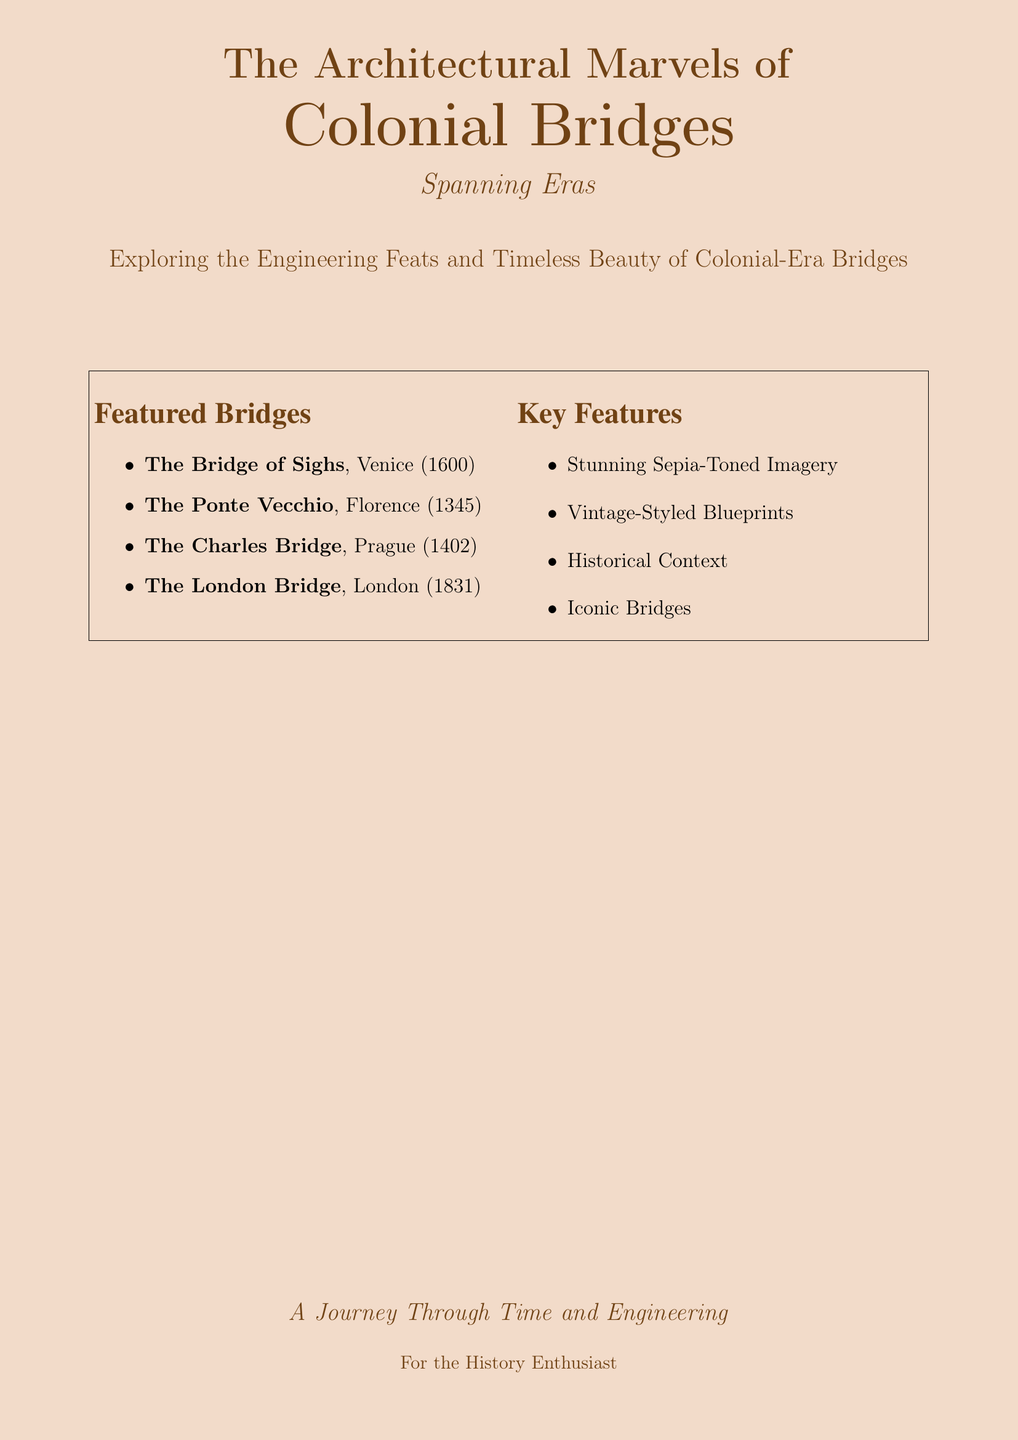What is the title of the book? The title is prominently displayed at the top of the cover.
Answer: The Architectural Marvels of Colonial Bridges What does the subtitle say? The subtitle is located below the main title on the cover.
Answer: Spanning Eras What year was the Bridge of Sighs built? The year is indicated next to the bridge name in the Featured Bridges section.
Answer: 1600 How many featured bridges are listed? The number of items in the Featured Bridges section indicates this.
Answer: Four What kind of imagery is featured in the book? This information is found under the Key Features section on the cover.
Answer: Stunning Sepia-Toned Imagery Which bridge is associated with London? The name of the bridge is explicitly mentioned in the Featured Bridges section.
Answer: The London Bridge What is the purpose of this document? The overall intent of the document can be inferred from the main focal text at the bottom.
Answer: A Journey Through Time and Engineering Who is the intended audience for this book? This information is found at the bottom of the cover.
Answer: For the History Enthusiast 